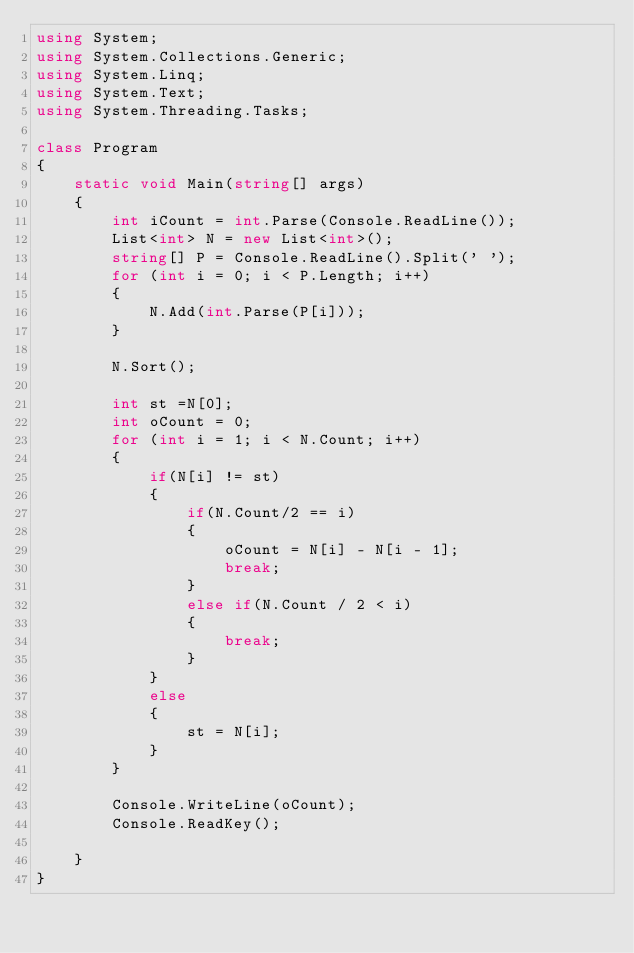Convert code to text. <code><loc_0><loc_0><loc_500><loc_500><_C#_>using System;
using System.Collections.Generic;
using System.Linq;
using System.Text;
using System.Threading.Tasks;

class Program
{
    static void Main(string[] args)
    {
        int iCount = int.Parse(Console.ReadLine());
        List<int> N = new List<int>();
        string[] P = Console.ReadLine().Split(' ');
        for (int i = 0; i < P.Length; i++)
        {
            N.Add(int.Parse(P[i]));
        }

        N.Sort();

        int st =N[0];
        int oCount = 0;
        for (int i = 1; i < N.Count; i++)
        {
            if(N[i] != st)
            {
                if(N.Count/2 == i)
                {
                    oCount = N[i] - N[i - 1]; 
                    break;
                }
                else if(N.Count / 2 < i)
                {
                    break;
                }
            }
            else
            {
                st = N[i];
            }
        }

        Console.WriteLine(oCount);
        Console.ReadKey();

    }
}
</code> 